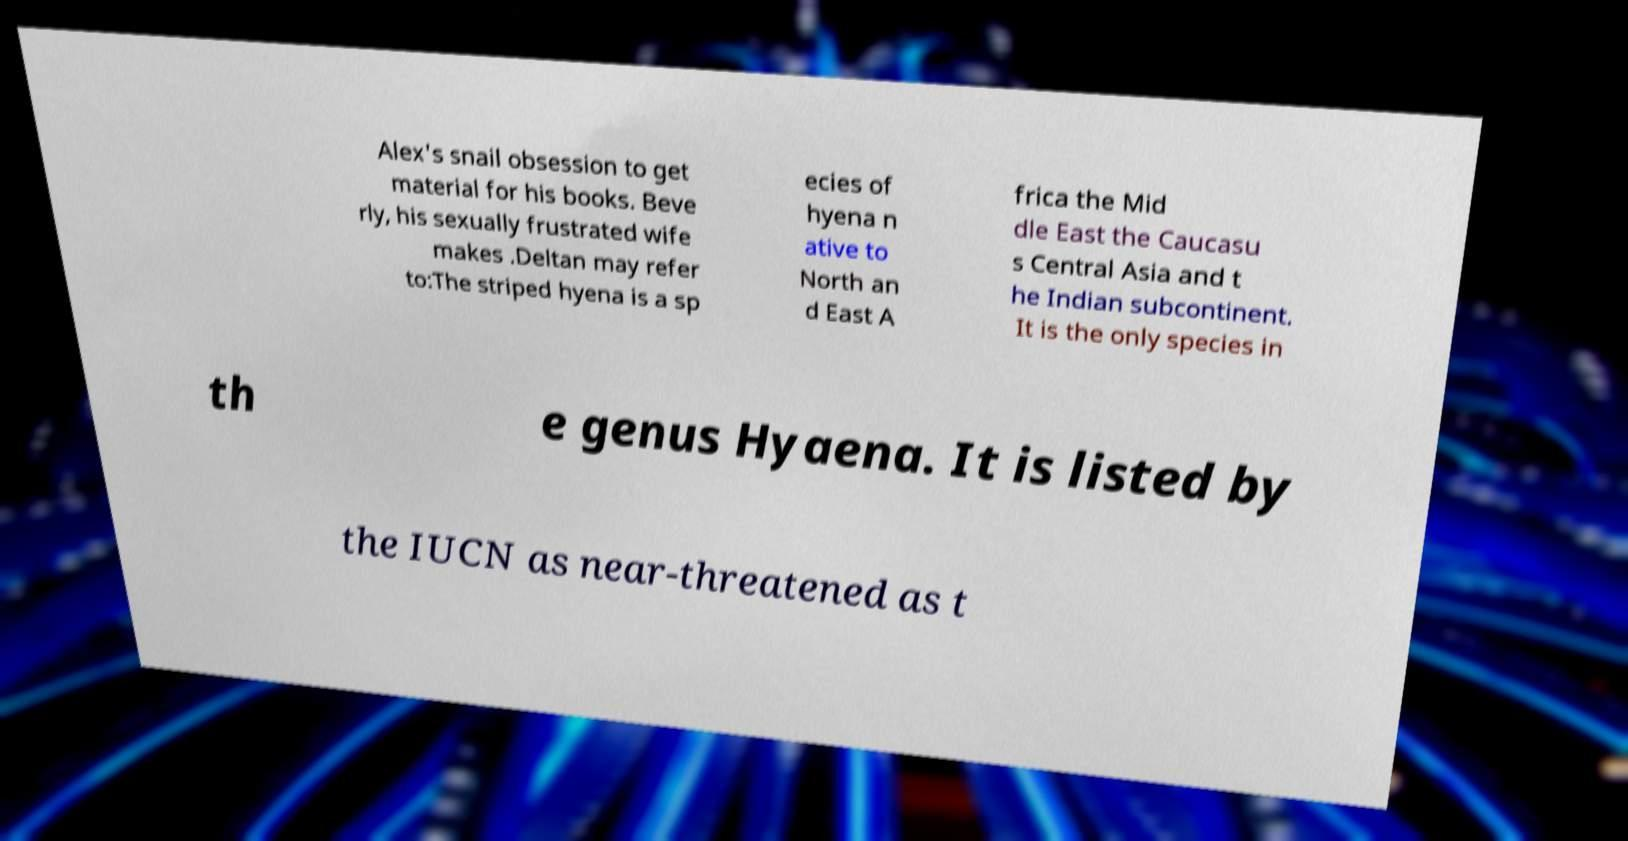Please identify and transcribe the text found in this image. Alex's snail obsession to get material for his books. Beve rly, his sexually frustrated wife makes .Deltan may refer to:The striped hyena is a sp ecies of hyena n ative to North an d East A frica the Mid dle East the Caucasu s Central Asia and t he Indian subcontinent. It is the only species in th e genus Hyaena. It is listed by the IUCN as near-threatened as t 